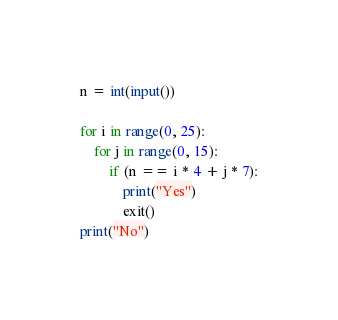<code> <loc_0><loc_0><loc_500><loc_500><_Python_>n = int(input())

for i in range(0, 25):
    for j in range(0, 15):
        if (n == i * 4 + j * 7):
            print("Yes")
            exit()
print("No")
</code> 